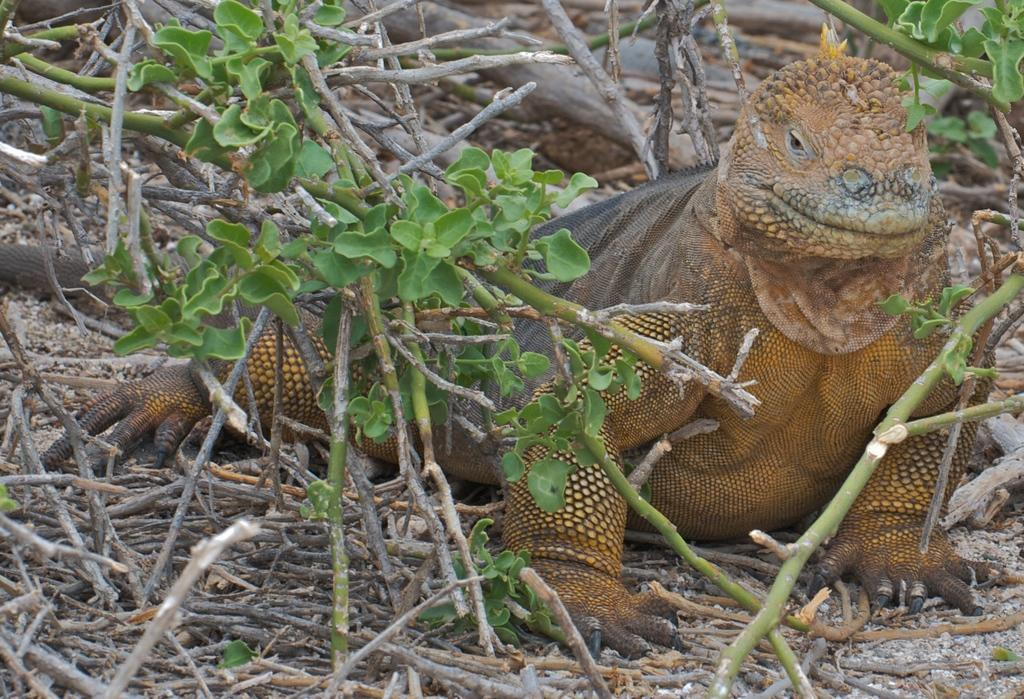What type of animal is in the image? There is a reptile in the image. Where is the reptile located? The reptile is on the twigs. What is the reptile resting on? The twigs are on the ground. What can be seen in the background of the image? There are plants in the background of the image. What type of soda is the reptile drinking in the image? There is no soda present in the image; the reptile is resting on twigs on the ground. 